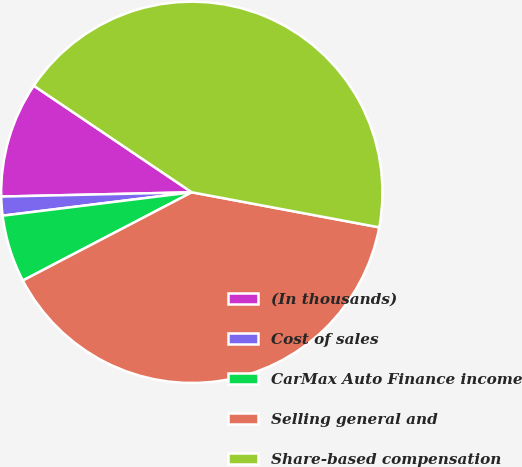Convert chart to OTSL. <chart><loc_0><loc_0><loc_500><loc_500><pie_chart><fcel>(In thousands)<fcel>Cost of sales<fcel>CarMax Auto Finance income<fcel>Selling general and<fcel>Share-based compensation<nl><fcel>9.8%<fcel>1.6%<fcel>5.7%<fcel>39.4%<fcel>43.5%<nl></chart> 